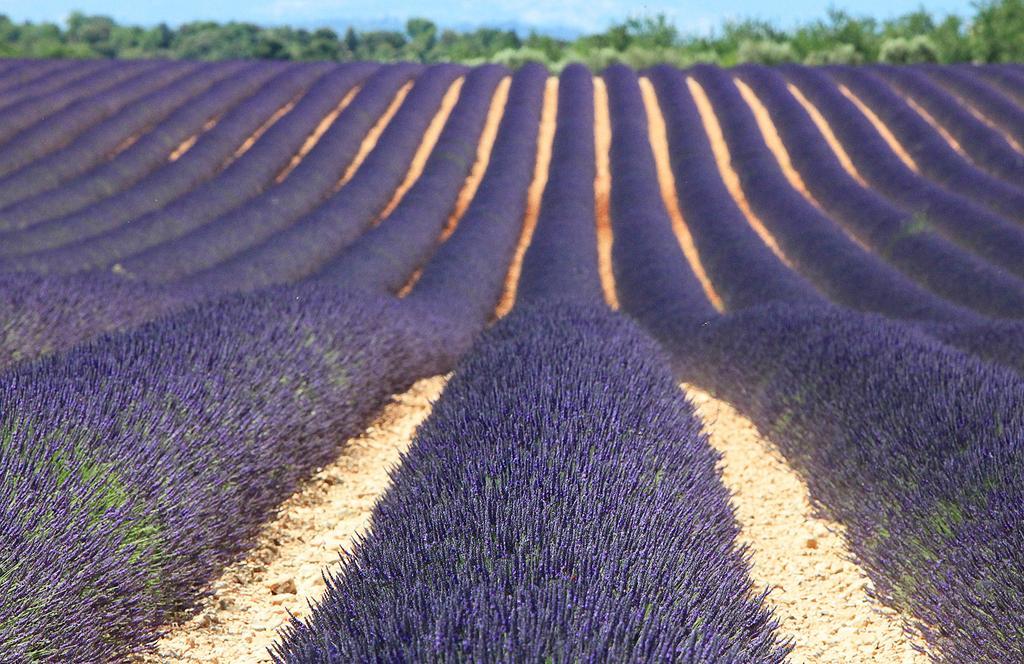Can you describe this image briefly? In this image we can see some plants with flowers on it, in the background, we can see some trees and the sky with clouds. 